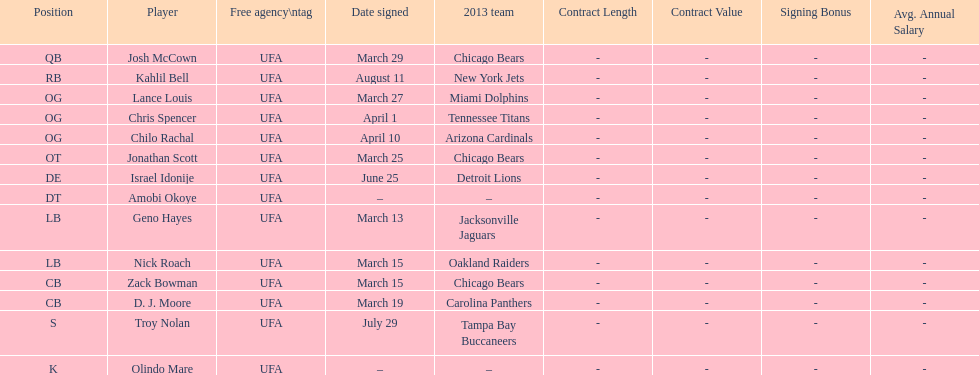How many free agents did this team pick up this season? 14. 